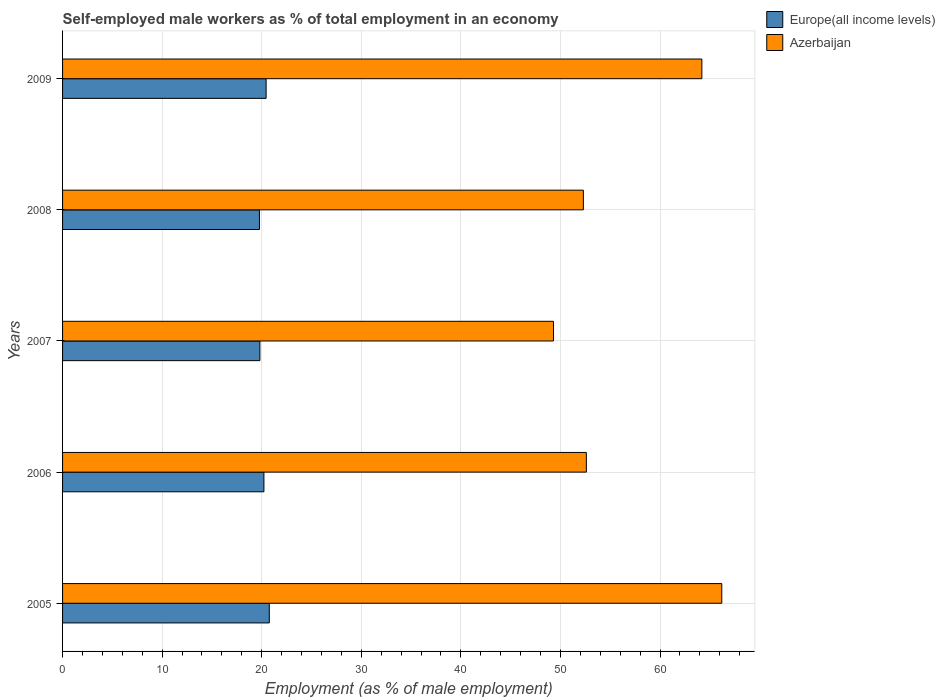Are the number of bars per tick equal to the number of legend labels?
Your answer should be very brief. Yes. Are the number of bars on each tick of the Y-axis equal?
Ensure brevity in your answer.  Yes. How many bars are there on the 3rd tick from the top?
Offer a very short reply. 2. How many bars are there on the 4th tick from the bottom?
Give a very brief answer. 2. In how many cases, is the number of bars for a given year not equal to the number of legend labels?
Your answer should be compact. 0. What is the percentage of self-employed male workers in Europe(all income levels) in 2009?
Keep it short and to the point. 20.44. Across all years, what is the maximum percentage of self-employed male workers in Europe(all income levels)?
Give a very brief answer. 20.76. Across all years, what is the minimum percentage of self-employed male workers in Europe(all income levels)?
Offer a very short reply. 19.77. In which year was the percentage of self-employed male workers in Azerbaijan minimum?
Ensure brevity in your answer.  2007. What is the total percentage of self-employed male workers in Europe(all income levels) in the graph?
Keep it short and to the point. 101.01. What is the difference between the percentage of self-employed male workers in Azerbaijan in 2007 and that in 2009?
Your answer should be compact. -14.9. What is the difference between the percentage of self-employed male workers in Europe(all income levels) in 2006 and the percentage of self-employed male workers in Azerbaijan in 2007?
Make the answer very short. -29.08. What is the average percentage of self-employed male workers in Europe(all income levels) per year?
Your answer should be compact. 20.2. In the year 2006, what is the difference between the percentage of self-employed male workers in Azerbaijan and percentage of self-employed male workers in Europe(all income levels)?
Your answer should be very brief. 32.38. In how many years, is the percentage of self-employed male workers in Europe(all income levels) greater than 52 %?
Offer a very short reply. 0. What is the ratio of the percentage of self-employed male workers in Europe(all income levels) in 2007 to that in 2008?
Give a very brief answer. 1. Is the percentage of self-employed male workers in Europe(all income levels) in 2005 less than that in 2009?
Your answer should be compact. No. What is the difference between the highest and the second highest percentage of self-employed male workers in Europe(all income levels)?
Ensure brevity in your answer.  0.32. What is the difference between the highest and the lowest percentage of self-employed male workers in Europe(all income levels)?
Offer a terse response. 0.99. In how many years, is the percentage of self-employed male workers in Europe(all income levels) greater than the average percentage of self-employed male workers in Europe(all income levels) taken over all years?
Make the answer very short. 3. Is the sum of the percentage of self-employed male workers in Europe(all income levels) in 2007 and 2009 greater than the maximum percentage of self-employed male workers in Azerbaijan across all years?
Your answer should be very brief. No. What does the 2nd bar from the top in 2006 represents?
Give a very brief answer. Europe(all income levels). What does the 2nd bar from the bottom in 2009 represents?
Offer a terse response. Azerbaijan. Are all the bars in the graph horizontal?
Make the answer very short. Yes. What is the difference between two consecutive major ticks on the X-axis?
Your answer should be compact. 10. Does the graph contain any zero values?
Provide a short and direct response. No. Where does the legend appear in the graph?
Offer a terse response. Top right. What is the title of the graph?
Make the answer very short. Self-employed male workers as % of total employment in an economy. What is the label or title of the X-axis?
Offer a very short reply. Employment (as % of male employment). What is the label or title of the Y-axis?
Your answer should be compact. Years. What is the Employment (as % of male employment) of Europe(all income levels) in 2005?
Make the answer very short. 20.76. What is the Employment (as % of male employment) of Azerbaijan in 2005?
Your answer should be compact. 66.2. What is the Employment (as % of male employment) in Europe(all income levels) in 2006?
Make the answer very short. 20.22. What is the Employment (as % of male employment) of Azerbaijan in 2006?
Your answer should be very brief. 52.6. What is the Employment (as % of male employment) of Europe(all income levels) in 2007?
Offer a terse response. 19.82. What is the Employment (as % of male employment) in Azerbaijan in 2007?
Offer a very short reply. 49.3. What is the Employment (as % of male employment) of Europe(all income levels) in 2008?
Keep it short and to the point. 19.77. What is the Employment (as % of male employment) of Azerbaijan in 2008?
Provide a short and direct response. 52.3. What is the Employment (as % of male employment) in Europe(all income levels) in 2009?
Ensure brevity in your answer.  20.44. What is the Employment (as % of male employment) of Azerbaijan in 2009?
Give a very brief answer. 64.2. Across all years, what is the maximum Employment (as % of male employment) in Europe(all income levels)?
Your answer should be very brief. 20.76. Across all years, what is the maximum Employment (as % of male employment) of Azerbaijan?
Offer a terse response. 66.2. Across all years, what is the minimum Employment (as % of male employment) in Europe(all income levels)?
Offer a very short reply. 19.77. Across all years, what is the minimum Employment (as % of male employment) in Azerbaijan?
Offer a very short reply. 49.3. What is the total Employment (as % of male employment) of Europe(all income levels) in the graph?
Provide a short and direct response. 101.01. What is the total Employment (as % of male employment) in Azerbaijan in the graph?
Keep it short and to the point. 284.6. What is the difference between the Employment (as % of male employment) in Europe(all income levels) in 2005 and that in 2006?
Keep it short and to the point. 0.54. What is the difference between the Employment (as % of male employment) in Europe(all income levels) in 2005 and that in 2007?
Keep it short and to the point. 0.94. What is the difference between the Employment (as % of male employment) in Europe(all income levels) in 2005 and that in 2008?
Your answer should be compact. 0.99. What is the difference between the Employment (as % of male employment) in Azerbaijan in 2005 and that in 2008?
Your answer should be compact. 13.9. What is the difference between the Employment (as % of male employment) in Europe(all income levels) in 2005 and that in 2009?
Provide a short and direct response. 0.32. What is the difference between the Employment (as % of male employment) of Europe(all income levels) in 2006 and that in 2007?
Ensure brevity in your answer.  0.4. What is the difference between the Employment (as % of male employment) of Azerbaijan in 2006 and that in 2007?
Your answer should be very brief. 3.3. What is the difference between the Employment (as % of male employment) of Europe(all income levels) in 2006 and that in 2008?
Ensure brevity in your answer.  0.45. What is the difference between the Employment (as % of male employment) in Azerbaijan in 2006 and that in 2008?
Offer a terse response. 0.3. What is the difference between the Employment (as % of male employment) of Europe(all income levels) in 2006 and that in 2009?
Keep it short and to the point. -0.22. What is the difference between the Employment (as % of male employment) in Europe(all income levels) in 2007 and that in 2008?
Offer a very short reply. 0.05. What is the difference between the Employment (as % of male employment) in Europe(all income levels) in 2007 and that in 2009?
Make the answer very short. -0.63. What is the difference between the Employment (as % of male employment) in Azerbaijan in 2007 and that in 2009?
Your answer should be compact. -14.9. What is the difference between the Employment (as % of male employment) of Europe(all income levels) in 2008 and that in 2009?
Keep it short and to the point. -0.67. What is the difference between the Employment (as % of male employment) in Azerbaijan in 2008 and that in 2009?
Your answer should be very brief. -11.9. What is the difference between the Employment (as % of male employment) of Europe(all income levels) in 2005 and the Employment (as % of male employment) of Azerbaijan in 2006?
Keep it short and to the point. -31.84. What is the difference between the Employment (as % of male employment) in Europe(all income levels) in 2005 and the Employment (as % of male employment) in Azerbaijan in 2007?
Make the answer very short. -28.54. What is the difference between the Employment (as % of male employment) of Europe(all income levels) in 2005 and the Employment (as % of male employment) of Azerbaijan in 2008?
Provide a succinct answer. -31.54. What is the difference between the Employment (as % of male employment) in Europe(all income levels) in 2005 and the Employment (as % of male employment) in Azerbaijan in 2009?
Offer a terse response. -43.44. What is the difference between the Employment (as % of male employment) of Europe(all income levels) in 2006 and the Employment (as % of male employment) of Azerbaijan in 2007?
Ensure brevity in your answer.  -29.08. What is the difference between the Employment (as % of male employment) of Europe(all income levels) in 2006 and the Employment (as % of male employment) of Azerbaijan in 2008?
Give a very brief answer. -32.08. What is the difference between the Employment (as % of male employment) of Europe(all income levels) in 2006 and the Employment (as % of male employment) of Azerbaijan in 2009?
Make the answer very short. -43.98. What is the difference between the Employment (as % of male employment) of Europe(all income levels) in 2007 and the Employment (as % of male employment) of Azerbaijan in 2008?
Your answer should be very brief. -32.48. What is the difference between the Employment (as % of male employment) of Europe(all income levels) in 2007 and the Employment (as % of male employment) of Azerbaijan in 2009?
Provide a succinct answer. -44.38. What is the difference between the Employment (as % of male employment) in Europe(all income levels) in 2008 and the Employment (as % of male employment) in Azerbaijan in 2009?
Give a very brief answer. -44.43. What is the average Employment (as % of male employment) in Europe(all income levels) per year?
Offer a terse response. 20.2. What is the average Employment (as % of male employment) of Azerbaijan per year?
Your response must be concise. 56.92. In the year 2005, what is the difference between the Employment (as % of male employment) in Europe(all income levels) and Employment (as % of male employment) in Azerbaijan?
Provide a short and direct response. -45.44. In the year 2006, what is the difference between the Employment (as % of male employment) of Europe(all income levels) and Employment (as % of male employment) of Azerbaijan?
Keep it short and to the point. -32.38. In the year 2007, what is the difference between the Employment (as % of male employment) in Europe(all income levels) and Employment (as % of male employment) in Azerbaijan?
Offer a very short reply. -29.48. In the year 2008, what is the difference between the Employment (as % of male employment) of Europe(all income levels) and Employment (as % of male employment) of Azerbaijan?
Keep it short and to the point. -32.53. In the year 2009, what is the difference between the Employment (as % of male employment) in Europe(all income levels) and Employment (as % of male employment) in Azerbaijan?
Ensure brevity in your answer.  -43.76. What is the ratio of the Employment (as % of male employment) in Europe(all income levels) in 2005 to that in 2006?
Make the answer very short. 1.03. What is the ratio of the Employment (as % of male employment) of Azerbaijan in 2005 to that in 2006?
Make the answer very short. 1.26. What is the ratio of the Employment (as % of male employment) of Europe(all income levels) in 2005 to that in 2007?
Offer a terse response. 1.05. What is the ratio of the Employment (as % of male employment) in Azerbaijan in 2005 to that in 2007?
Your answer should be very brief. 1.34. What is the ratio of the Employment (as % of male employment) of Azerbaijan in 2005 to that in 2008?
Provide a succinct answer. 1.27. What is the ratio of the Employment (as % of male employment) in Europe(all income levels) in 2005 to that in 2009?
Offer a very short reply. 1.02. What is the ratio of the Employment (as % of male employment) in Azerbaijan in 2005 to that in 2009?
Your response must be concise. 1.03. What is the ratio of the Employment (as % of male employment) of Europe(all income levels) in 2006 to that in 2007?
Provide a succinct answer. 1.02. What is the ratio of the Employment (as % of male employment) of Azerbaijan in 2006 to that in 2007?
Your answer should be very brief. 1.07. What is the ratio of the Employment (as % of male employment) of Europe(all income levels) in 2006 to that in 2008?
Your answer should be compact. 1.02. What is the ratio of the Employment (as % of male employment) in Azerbaijan in 2006 to that in 2009?
Make the answer very short. 0.82. What is the ratio of the Employment (as % of male employment) in Europe(all income levels) in 2007 to that in 2008?
Give a very brief answer. 1. What is the ratio of the Employment (as % of male employment) of Azerbaijan in 2007 to that in 2008?
Your response must be concise. 0.94. What is the ratio of the Employment (as % of male employment) of Europe(all income levels) in 2007 to that in 2009?
Provide a succinct answer. 0.97. What is the ratio of the Employment (as % of male employment) in Azerbaijan in 2007 to that in 2009?
Offer a very short reply. 0.77. What is the ratio of the Employment (as % of male employment) in Europe(all income levels) in 2008 to that in 2009?
Ensure brevity in your answer.  0.97. What is the ratio of the Employment (as % of male employment) in Azerbaijan in 2008 to that in 2009?
Your response must be concise. 0.81. What is the difference between the highest and the second highest Employment (as % of male employment) of Europe(all income levels)?
Ensure brevity in your answer.  0.32. What is the difference between the highest and the second highest Employment (as % of male employment) in Azerbaijan?
Provide a short and direct response. 2. What is the difference between the highest and the lowest Employment (as % of male employment) of Europe(all income levels)?
Ensure brevity in your answer.  0.99. What is the difference between the highest and the lowest Employment (as % of male employment) of Azerbaijan?
Your answer should be very brief. 16.9. 